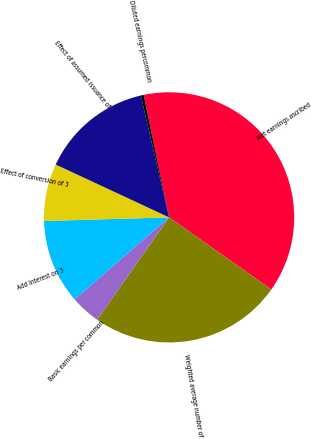<chart> <loc_0><loc_0><loc_500><loc_500><pie_chart><fcel>Net earnings ascribed<fcel>Weighted average number of<fcel>Basic earnings per common<fcel>Add Interest on 3<fcel>Effect of conversion of 3<fcel>Effect of assumed issuance of<fcel>Diluted earnings percommon<nl><fcel>38.04%<fcel>24.97%<fcel>3.88%<fcel>10.91%<fcel>7.4%<fcel>14.43%<fcel>0.37%<nl></chart> 